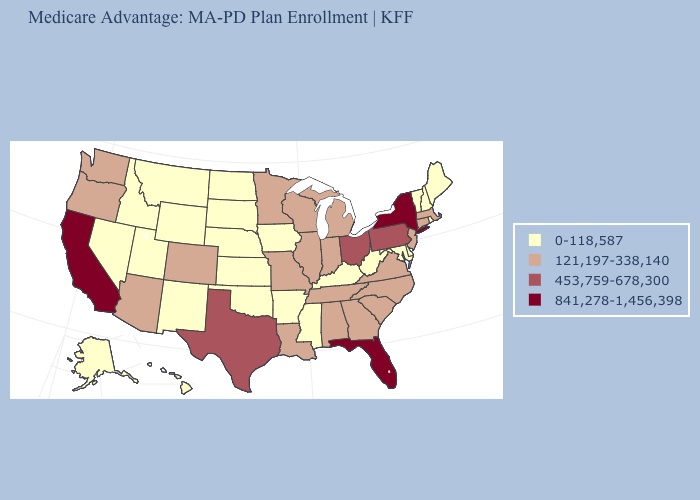What is the highest value in states that border Nevada?
Give a very brief answer. 841,278-1,456,398. Name the states that have a value in the range 0-118,587?
Write a very short answer. Alaska, Arkansas, Delaware, Hawaii, Iowa, Idaho, Kansas, Kentucky, Maryland, Maine, Mississippi, Montana, North Dakota, Nebraska, New Hampshire, New Mexico, Nevada, Oklahoma, Rhode Island, South Dakota, Utah, Vermont, West Virginia, Wyoming. How many symbols are there in the legend?
Give a very brief answer. 4. Among the states that border Washington , does Oregon have the lowest value?
Give a very brief answer. No. Does Wyoming have a lower value than Arizona?
Keep it brief. Yes. What is the value of Iowa?
Concise answer only. 0-118,587. Does the first symbol in the legend represent the smallest category?
Answer briefly. Yes. Name the states that have a value in the range 453,759-678,300?
Short answer required. Ohio, Pennsylvania, Texas. Name the states that have a value in the range 0-118,587?
Be succinct. Alaska, Arkansas, Delaware, Hawaii, Iowa, Idaho, Kansas, Kentucky, Maryland, Maine, Mississippi, Montana, North Dakota, Nebraska, New Hampshire, New Mexico, Nevada, Oklahoma, Rhode Island, South Dakota, Utah, Vermont, West Virginia, Wyoming. Does Oklahoma have the lowest value in the South?
Quick response, please. Yes. What is the value of New Mexico?
Write a very short answer. 0-118,587. What is the value of Ohio?
Give a very brief answer. 453,759-678,300. What is the value of Alaska?
Give a very brief answer. 0-118,587. Does the map have missing data?
Give a very brief answer. No. Name the states that have a value in the range 841,278-1,456,398?
Give a very brief answer. California, Florida, New York. 